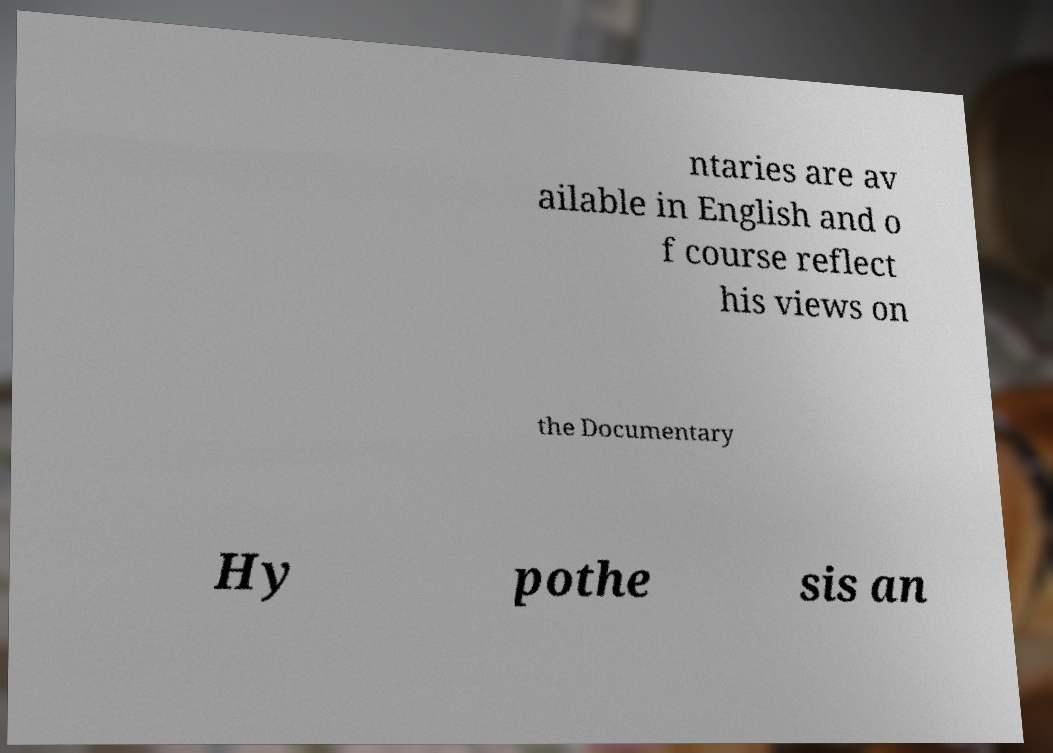There's text embedded in this image that I need extracted. Can you transcribe it verbatim? ntaries are av ailable in English and o f course reflect his views on the Documentary Hy pothe sis an 